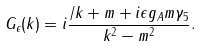Convert formula to latex. <formula><loc_0><loc_0><loc_500><loc_500>G _ { \epsilon } ( k ) = i \frac { \slash { k } + m + i \epsilon g _ { A } m \gamma _ { 5 } } { k ^ { 2 } - m ^ { 2 } } .</formula> 